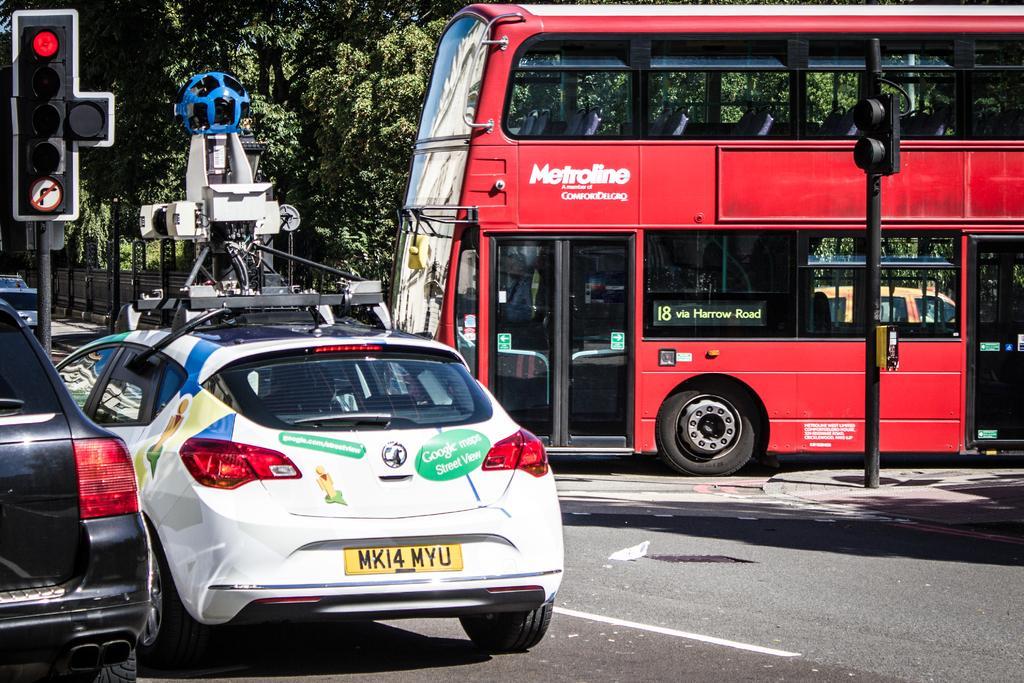Please provide a concise description of this image. In the image there are few cars going on road and a bus on the right side, there are traffic light poles on either side of the road, in the background there are trees. 